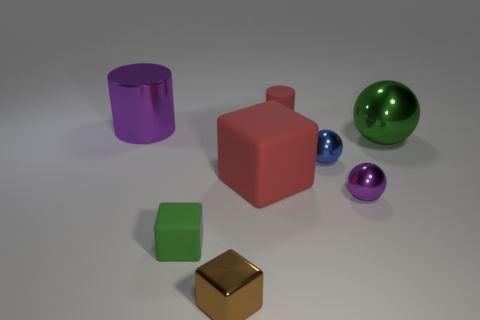Are there any other things that are the same color as the tiny metallic block?
Your answer should be very brief. No. What is the green ball made of?
Your answer should be very brief. Metal. The purple object that is the same size as the blue metal ball is what shape?
Provide a short and direct response. Sphere. Is there a block of the same color as the small matte cylinder?
Ensure brevity in your answer.  Yes. Do the small matte cylinder and the cube that is on the left side of the small brown metallic thing have the same color?
Offer a terse response. No. What is the color of the small matte object in front of the green object that is behind the purple sphere?
Ensure brevity in your answer.  Green. Is there a big rubber cube that is to the right of the block that is in front of the green object to the left of the red cylinder?
Keep it short and to the point. Yes. There is a cylinder that is the same material as the large red thing; what color is it?
Keep it short and to the point. Red. What number of large purple cylinders are the same material as the tiny blue sphere?
Your answer should be compact. 1. Do the big cylinder and the cylinder on the right side of the tiny green rubber block have the same material?
Make the answer very short. No. 